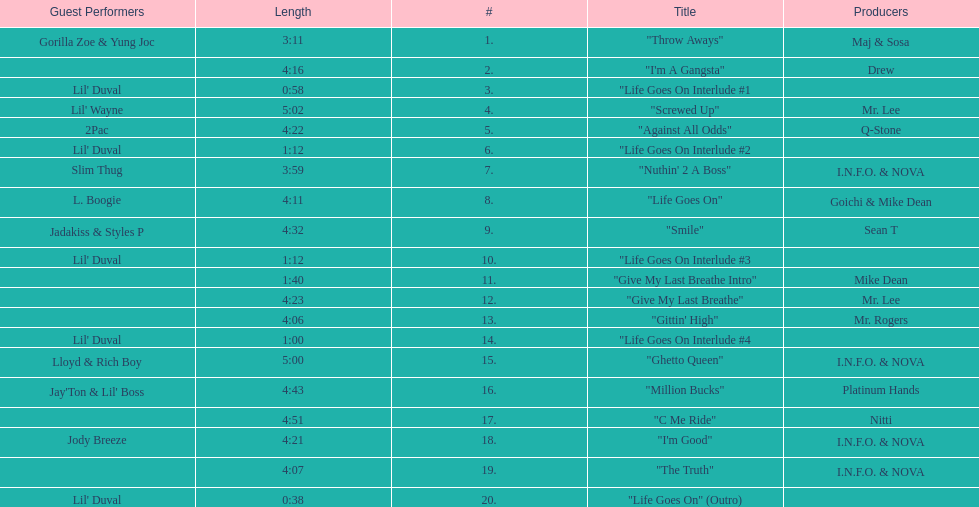How long is track number 11? 1:40. 